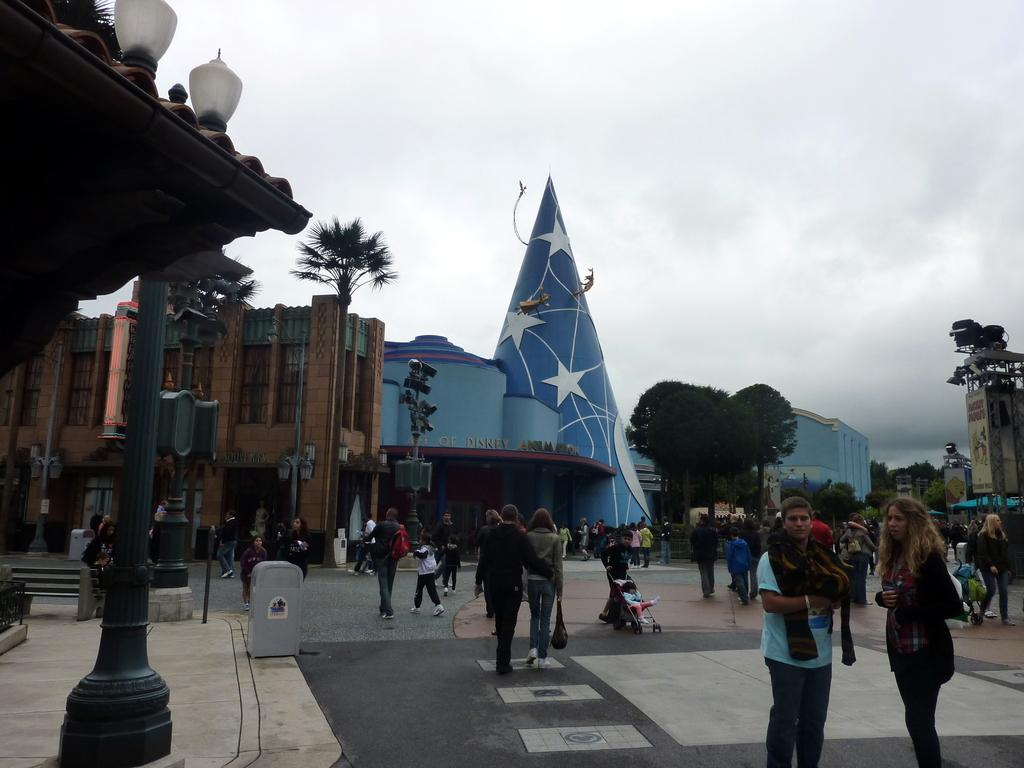What are the people in the image doing? The people in the image are on the floor. What structures can be seen in the image? There are buildings in the image. What type of vegetation is present in the image? There are trees in the image. What are the poles used for in the image? The poles are likely used for supporting lights or other objects in the image. What can be seen in the background of the image? The sky is visible in the background of the image. What type of crate is being used as a door in the image? There is no crate or door present in the image. 